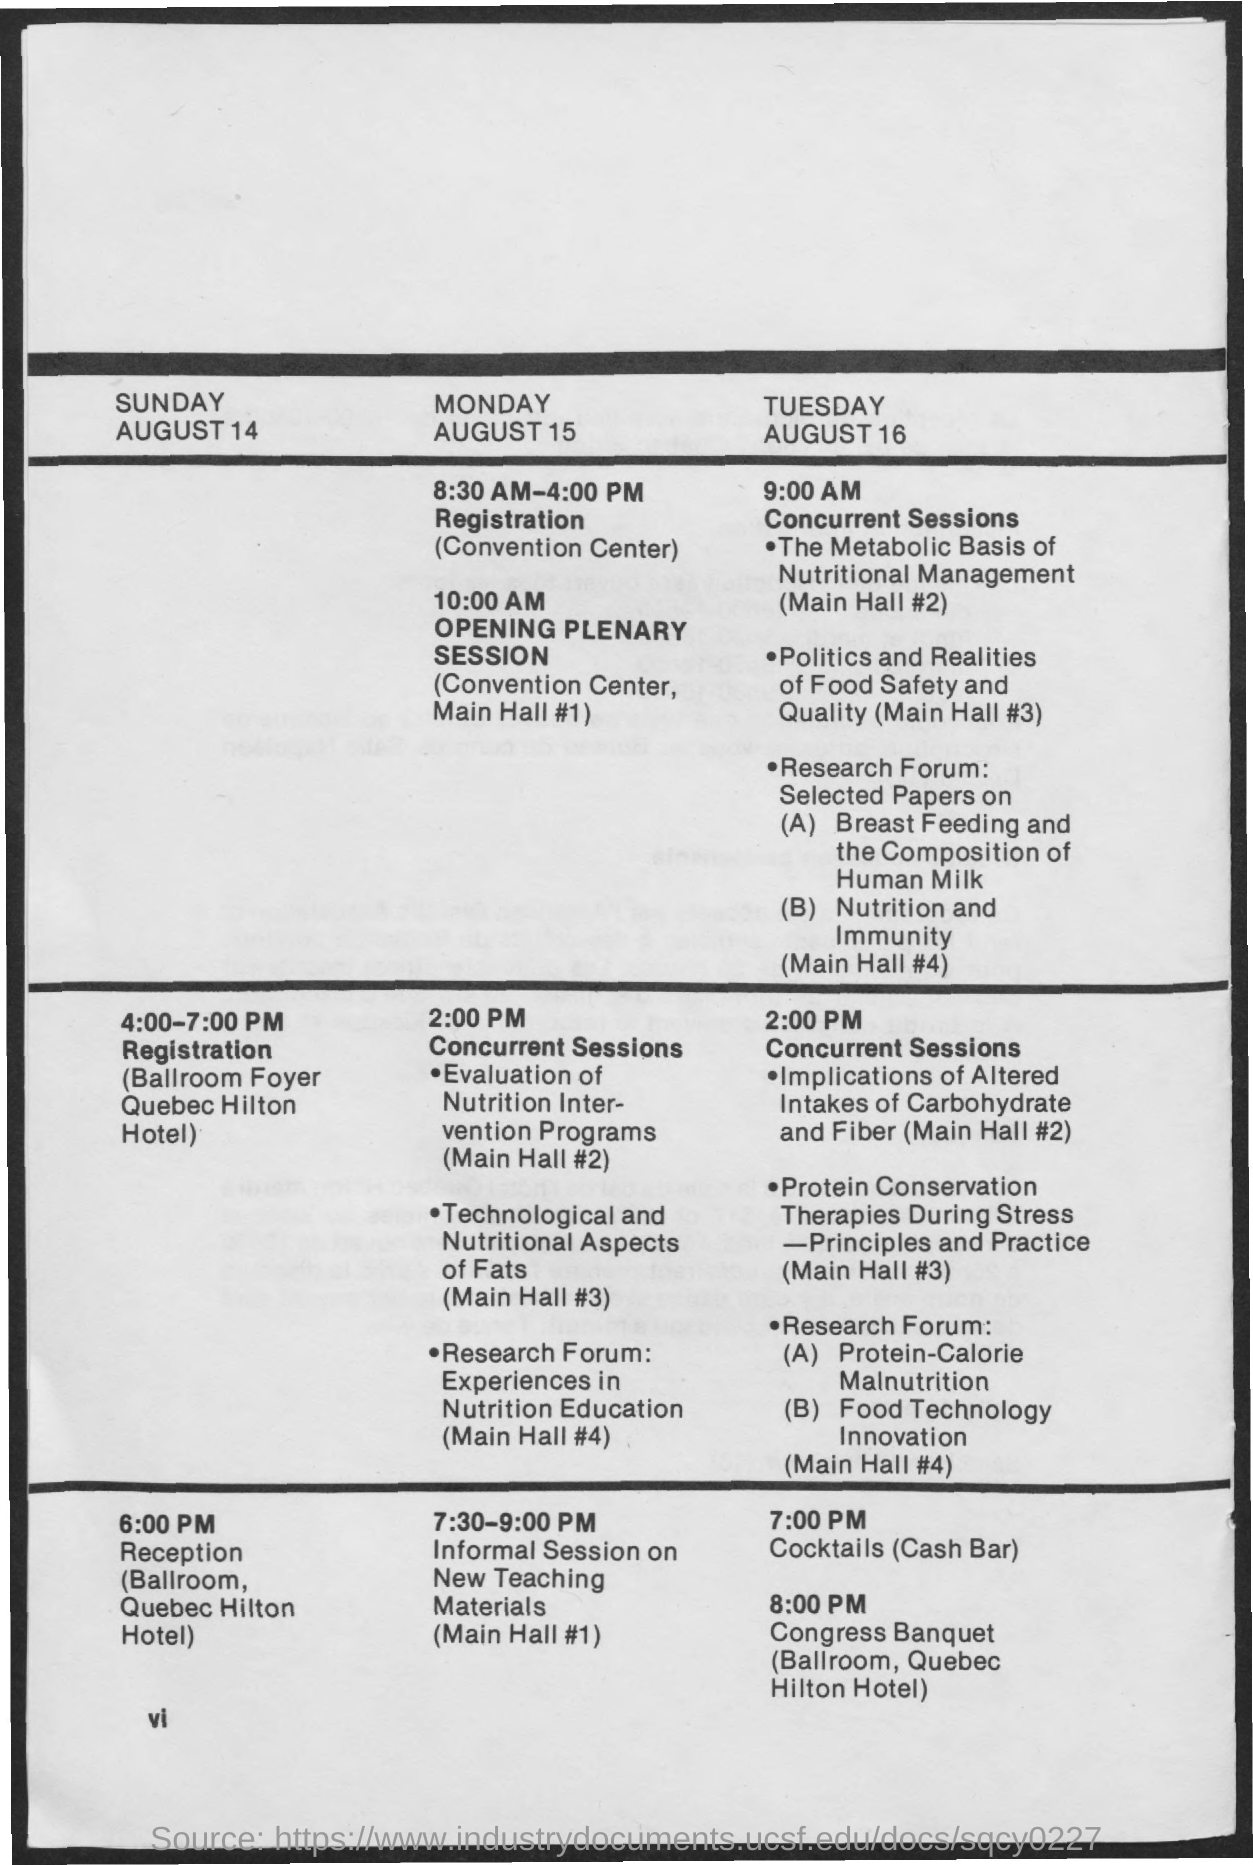Highlight a few significant elements in this photo. The timing for concurrent sessions on Monday, August 15 is 2:00 P.M. The registration timings for Monday, August 15 are from 8:30 AM to 4:00 PM. The timing for registration on Sunday, August 14 is from 4:00-7:00 PM. 